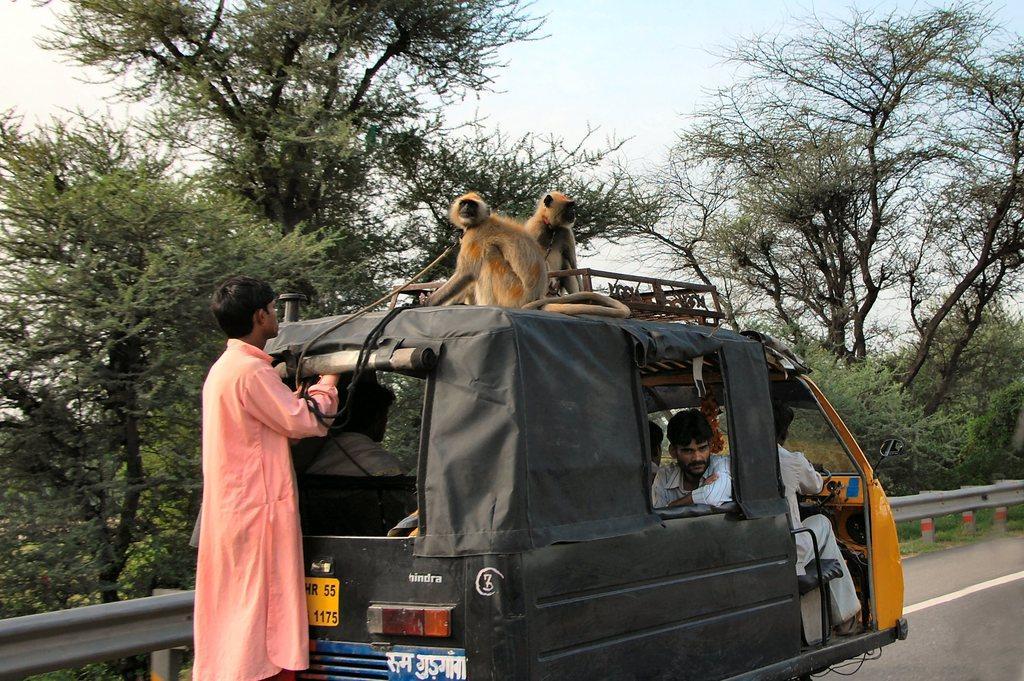Can you describe this image briefly? In this image in front there is an auto on the road. On top of the auto there are two monkeys and there is some object. In the auto there are people. In the background of the image there are trees and sky. 